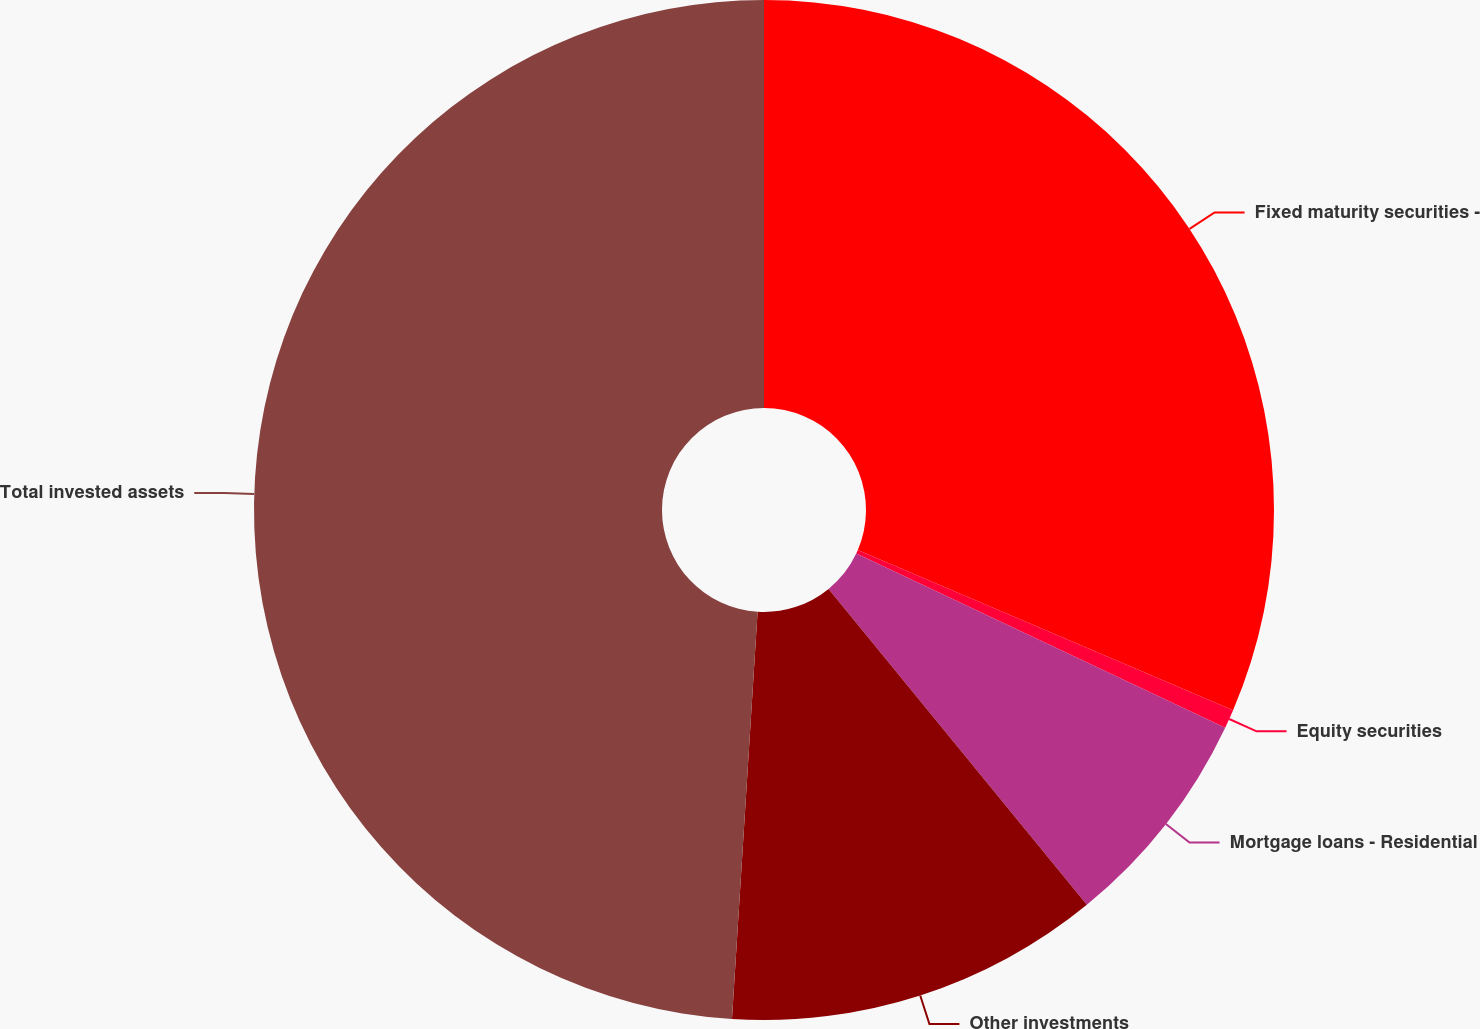Convert chart to OTSL. <chart><loc_0><loc_0><loc_500><loc_500><pie_chart><fcel>Fixed maturity securities -<fcel>Equity securities<fcel>Mortgage loans - Residential<fcel>Other investments<fcel>Total invested assets<nl><fcel>31.42%<fcel>0.6%<fcel>7.07%<fcel>11.91%<fcel>49.0%<nl></chart> 